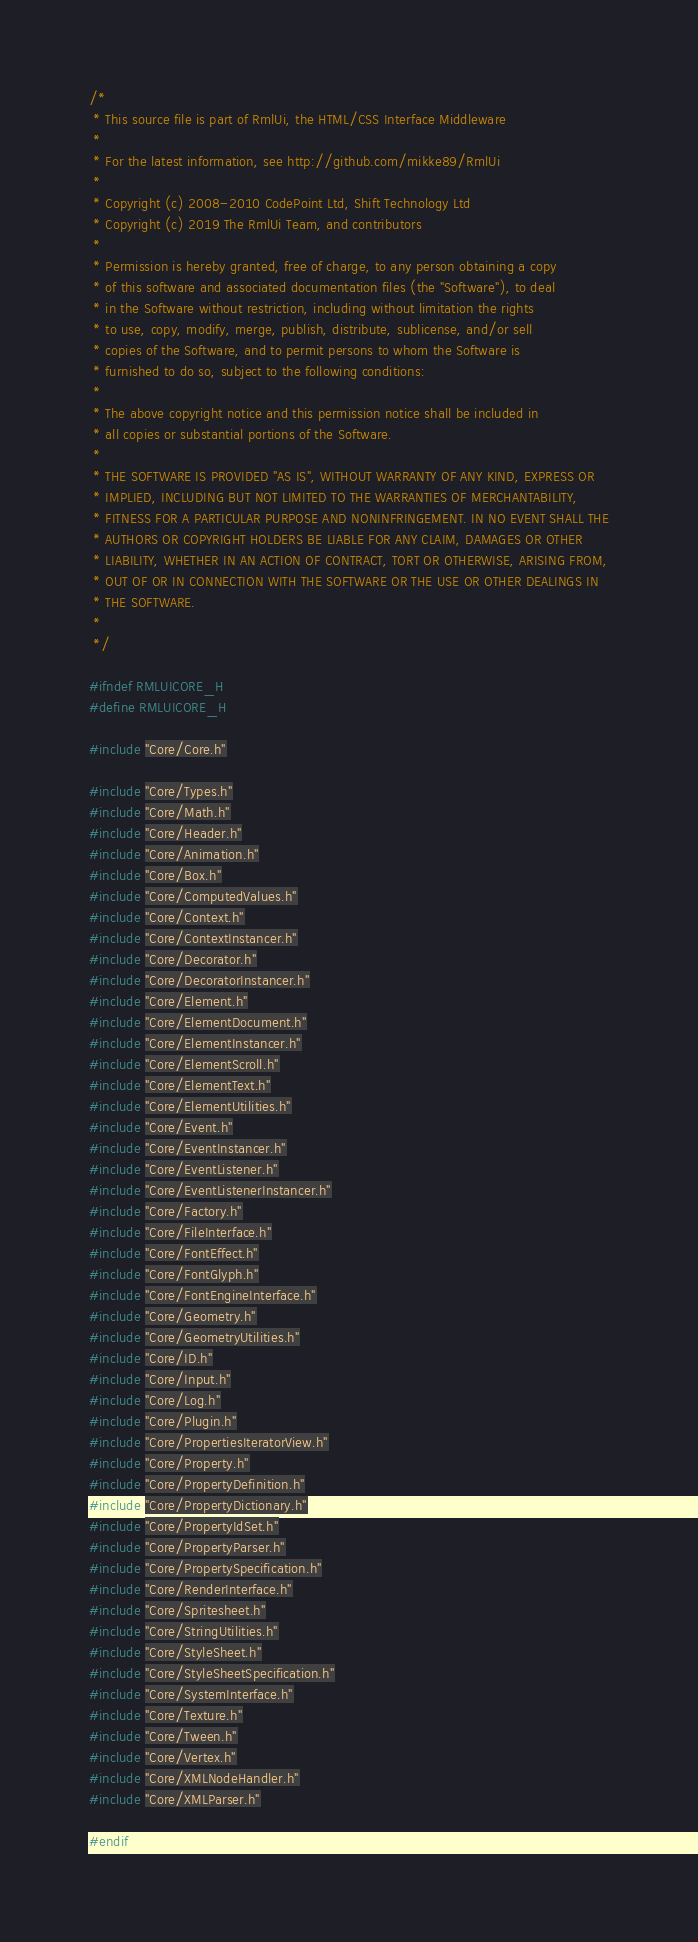<code> <loc_0><loc_0><loc_500><loc_500><_C_>/*
 * This source file is part of RmlUi, the HTML/CSS Interface Middleware
 *
 * For the latest information, see http://github.com/mikke89/RmlUi
 *
 * Copyright (c) 2008-2010 CodePoint Ltd, Shift Technology Ltd
 * Copyright (c) 2019 The RmlUi Team, and contributors
 *
 * Permission is hereby granted, free of charge, to any person obtaining a copy
 * of this software and associated documentation files (the "Software"), to deal
 * in the Software without restriction, including without limitation the rights
 * to use, copy, modify, merge, publish, distribute, sublicense, and/or sell
 * copies of the Software, and to permit persons to whom the Software is
 * furnished to do so, subject to the following conditions:
 *
 * The above copyright notice and this permission notice shall be included in
 * all copies or substantial portions of the Software.
 * 
 * THE SOFTWARE IS PROVIDED "AS IS", WITHOUT WARRANTY OF ANY KIND, EXPRESS OR
 * IMPLIED, INCLUDING BUT NOT LIMITED TO THE WARRANTIES OF MERCHANTABILITY,
 * FITNESS FOR A PARTICULAR PURPOSE AND NONINFRINGEMENT. IN NO EVENT SHALL THE
 * AUTHORS OR COPYRIGHT HOLDERS BE LIABLE FOR ANY CLAIM, DAMAGES OR OTHER
 * LIABILITY, WHETHER IN AN ACTION OF CONTRACT, TORT OR OTHERWISE, ARISING FROM,
 * OUT OF OR IN CONNECTION WITH THE SOFTWARE OR THE USE OR OTHER DEALINGS IN
 * THE SOFTWARE.
 *
 */

#ifndef RMLUICORE_H
#define RMLUICORE_H

#include "Core/Core.h"

#include "Core/Types.h"
#include "Core/Math.h"
#include "Core/Header.h"
#include "Core/Animation.h"
#include "Core/Box.h"
#include "Core/ComputedValues.h"
#include "Core/Context.h"
#include "Core/ContextInstancer.h"
#include "Core/Decorator.h"
#include "Core/DecoratorInstancer.h"
#include "Core/Element.h"
#include "Core/ElementDocument.h"
#include "Core/ElementInstancer.h"
#include "Core/ElementScroll.h"
#include "Core/ElementText.h"
#include "Core/ElementUtilities.h"
#include "Core/Event.h"
#include "Core/EventInstancer.h"
#include "Core/EventListener.h"
#include "Core/EventListenerInstancer.h"
#include "Core/Factory.h"
#include "Core/FileInterface.h"
#include "Core/FontEffect.h"
#include "Core/FontGlyph.h"
#include "Core/FontEngineInterface.h"
#include "Core/Geometry.h"
#include "Core/GeometryUtilities.h"
#include "Core/ID.h"
#include "Core/Input.h"
#include "Core/Log.h"
#include "Core/Plugin.h"
#include "Core/PropertiesIteratorView.h"
#include "Core/Property.h"
#include "Core/PropertyDefinition.h"
#include "Core/PropertyDictionary.h"
#include "Core/PropertyIdSet.h"
#include "Core/PropertyParser.h"
#include "Core/PropertySpecification.h"
#include "Core/RenderInterface.h"
#include "Core/Spritesheet.h"
#include "Core/StringUtilities.h"
#include "Core/StyleSheet.h"
#include "Core/StyleSheetSpecification.h"
#include "Core/SystemInterface.h"
#include "Core/Texture.h"
#include "Core/Tween.h"
#include "Core/Vertex.h"
#include "Core/XMLNodeHandler.h"
#include "Core/XMLParser.h"

#endif
</code> 